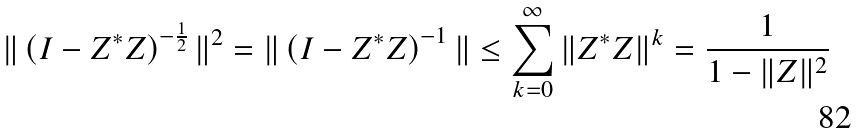Convert formula to latex. <formula><loc_0><loc_0><loc_500><loc_500>\| \left ( I - Z ^ { * } Z \right ) ^ { - \frac { 1 } { 2 } } \| ^ { 2 } = \| \left ( I - Z ^ { * } Z \right ) ^ { - 1 } \| \leq \sum _ { k = 0 } ^ { \infty } \| Z ^ { * } Z \| ^ { k } = \frac { 1 } { 1 - \| Z \| ^ { 2 } }</formula> 